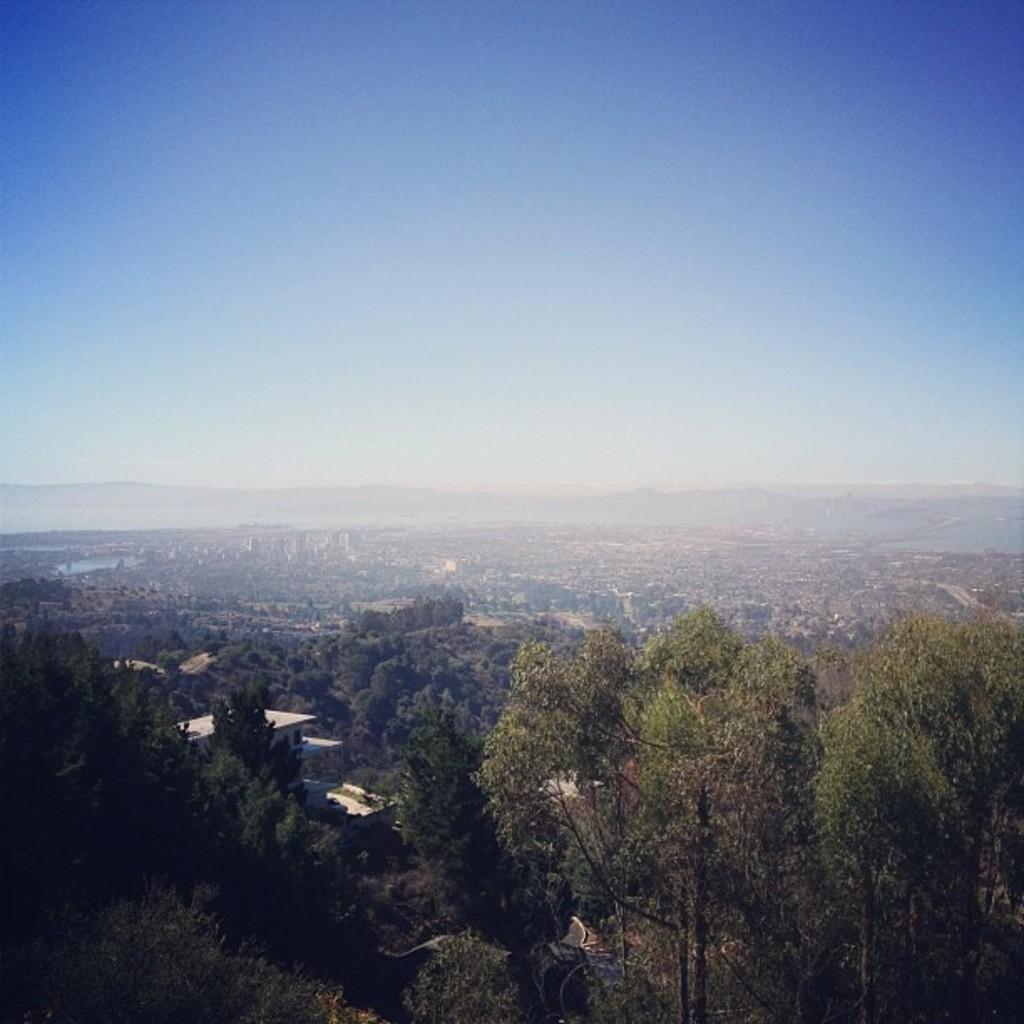In one or two sentences, can you explain what this image depicts? In this picture I can see the open land, building, trees, plants and grass. In the background I can see the mountain and water lake. At the top I can see the sky. 